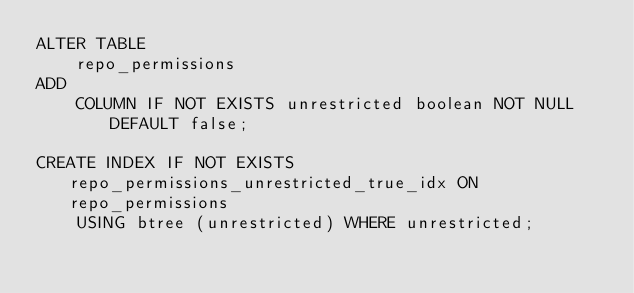<code> <loc_0><loc_0><loc_500><loc_500><_SQL_>ALTER TABLE
    repo_permissions
ADD
    COLUMN IF NOT EXISTS unrestricted boolean NOT NULL DEFAULT false;

CREATE INDEX IF NOT EXISTS repo_permissions_unrestricted_true_idx ON repo_permissions
    USING btree (unrestricted) WHERE unrestricted;

</code> 